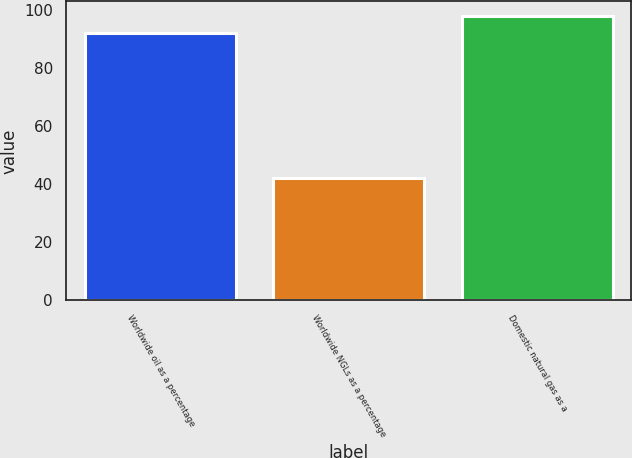<chart> <loc_0><loc_0><loc_500><loc_500><bar_chart><fcel>Worldwide oil as a percentage<fcel>Worldwide NGLs as a percentage<fcel>Domestic natural gas as a<nl><fcel>92<fcel>42<fcel>98<nl></chart> 